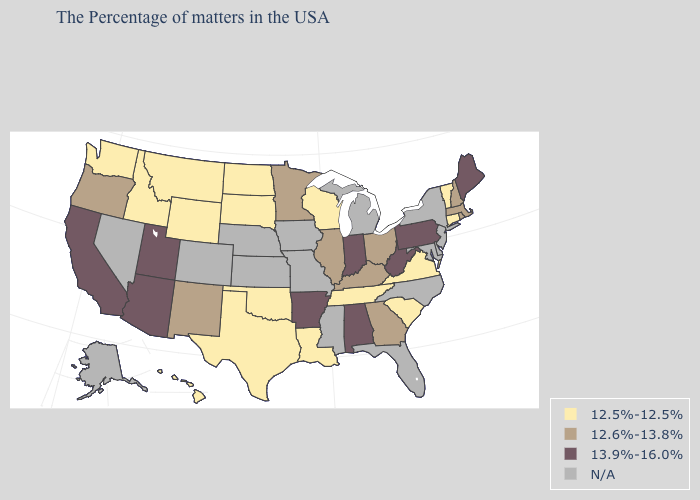Which states hav the highest value in the MidWest?
Keep it brief. Indiana. Does Washington have the lowest value in the West?
Write a very short answer. Yes. What is the value of Arkansas?
Write a very short answer. 13.9%-16.0%. What is the highest value in the Northeast ?
Write a very short answer. 13.9%-16.0%. Name the states that have a value in the range 13.9%-16.0%?
Be succinct. Maine, Pennsylvania, West Virginia, Indiana, Alabama, Arkansas, Utah, Arizona, California. Name the states that have a value in the range 13.9%-16.0%?
Give a very brief answer. Maine, Pennsylvania, West Virginia, Indiana, Alabama, Arkansas, Utah, Arizona, California. Which states hav the highest value in the MidWest?
Give a very brief answer. Indiana. What is the highest value in the West ?
Quick response, please. 13.9%-16.0%. What is the value of Tennessee?
Answer briefly. 12.5%-12.5%. Name the states that have a value in the range 13.9%-16.0%?
Quick response, please. Maine, Pennsylvania, West Virginia, Indiana, Alabama, Arkansas, Utah, Arizona, California. What is the lowest value in the Northeast?
Keep it brief. 12.5%-12.5%. What is the value of Wyoming?
Answer briefly. 12.5%-12.5%. What is the value of Ohio?
Write a very short answer. 12.6%-13.8%. Does Illinois have the lowest value in the MidWest?
Keep it brief. No. 